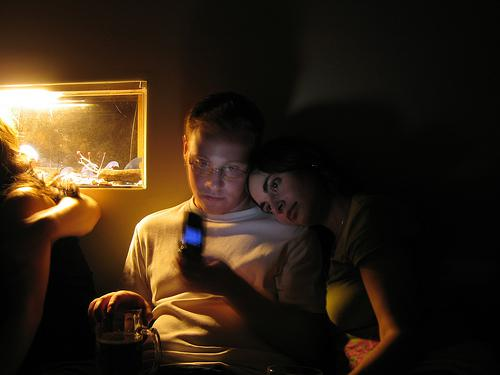Question: who is there?
Choices:
A. Man and lady.
B. Boy and dog.
C. Girl and horse.
D. Woman and cat.
Answer with the letter. Answer: A Question: what are the man and lady doing?
Choices:
A. Looking at phone.
B. Driving a car.
C. Flying in a helicopter.
D. Laying in bed.
Answer with the letter. Answer: A Question: who is the man with?
Choices:
A. Lady.
B. Friend.
C. Mother.
D. Boss.
Answer with the letter. Answer: A Question: who is the lady with?
Choices:
A. Man.
B. Sister.
C. Father.
D. Grandfather.
Answer with the letter. Answer: A Question: what is the man holding?
Choices:
A. Cup.
B. Sandwich.
C. Cell phone.
D. Kitten.
Answer with the letter. Answer: C Question: what is under the man's hand?
Choices:
A. Notebook.
B. Pen.
C. Desk.
D. Glass.
Answer with the letter. Answer: D 